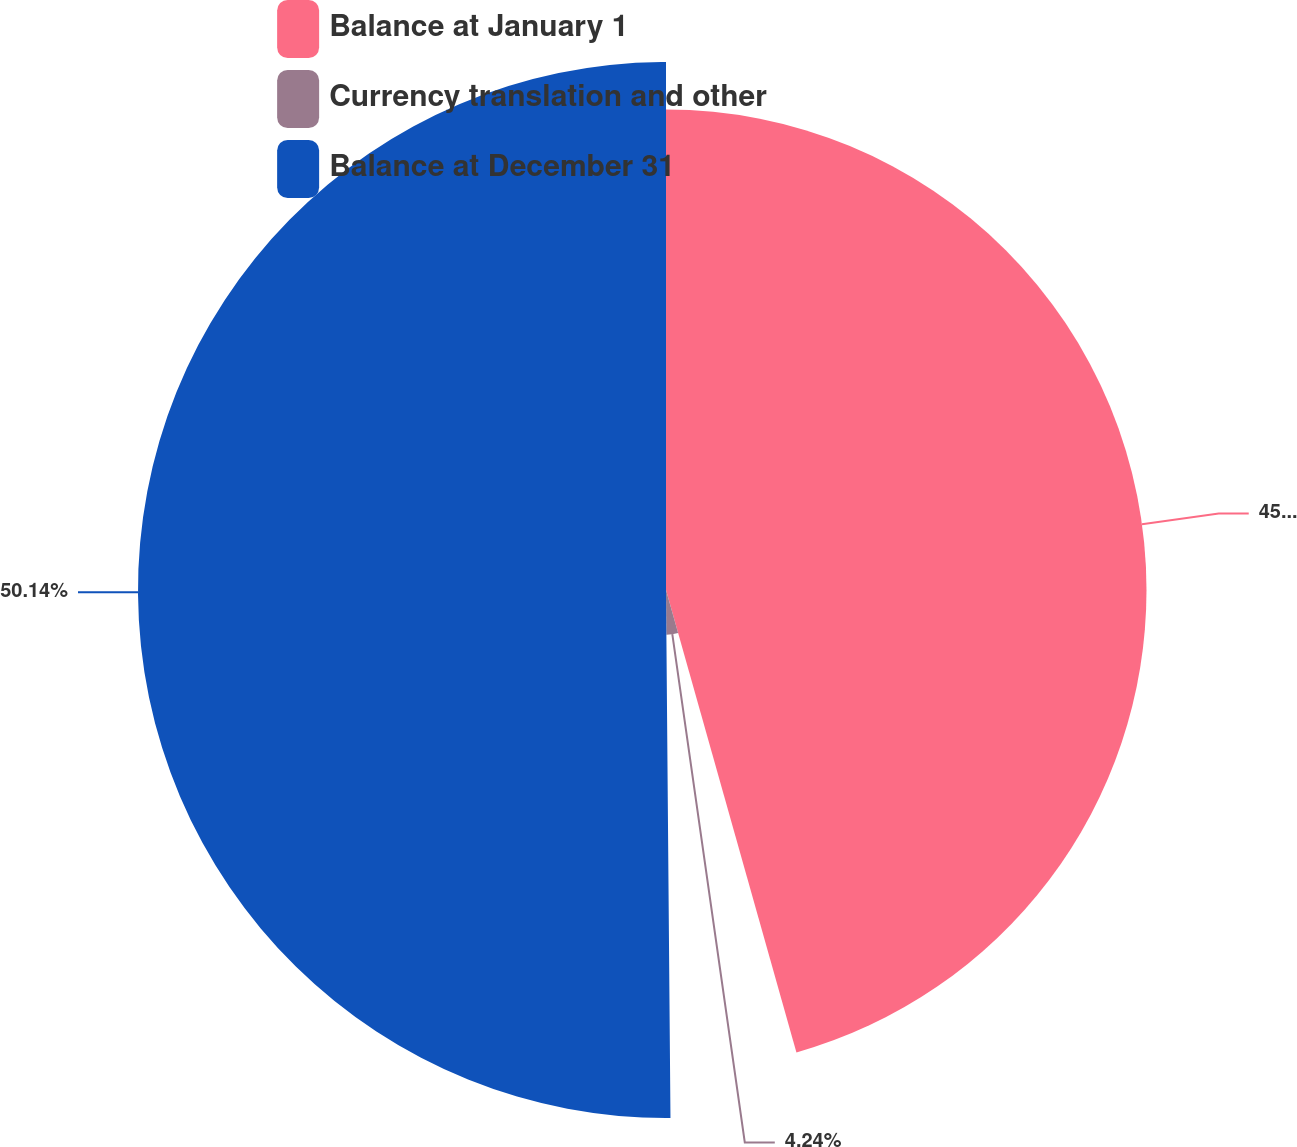<chart> <loc_0><loc_0><loc_500><loc_500><pie_chart><fcel>Balance at January 1<fcel>Currency translation and other<fcel>Balance at December 31<nl><fcel>45.62%<fcel>4.24%<fcel>50.13%<nl></chart> 